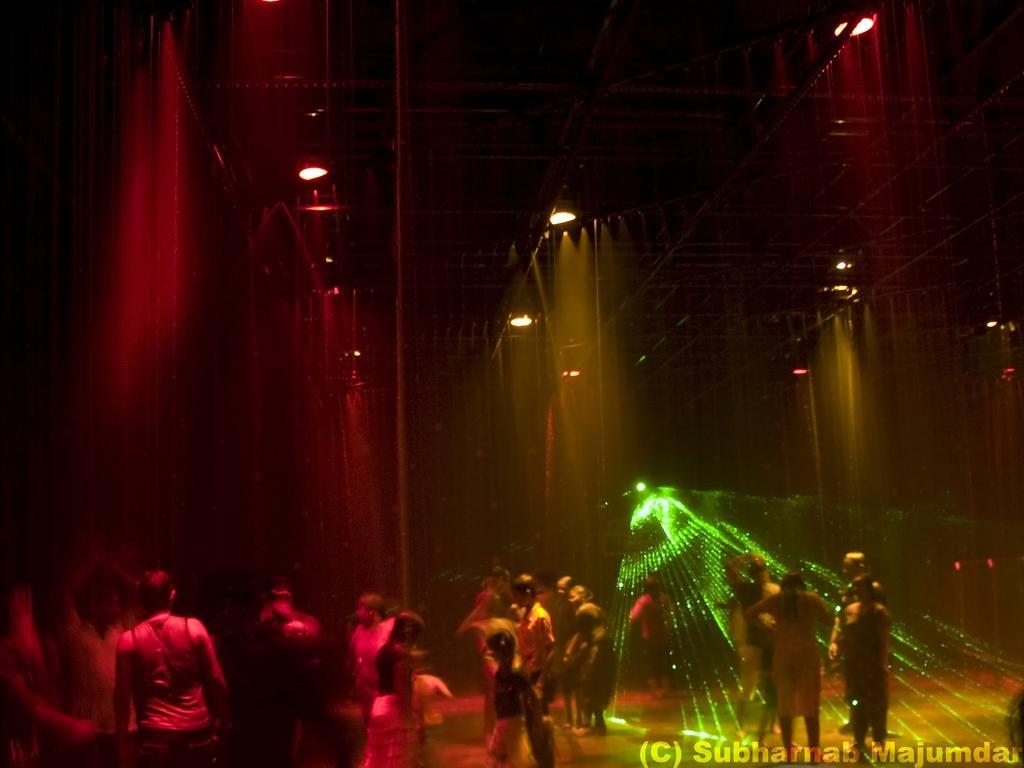Please provide a concise description of this image. In this image we can see some people standing under the shower. We can also see a roof and some lights. 